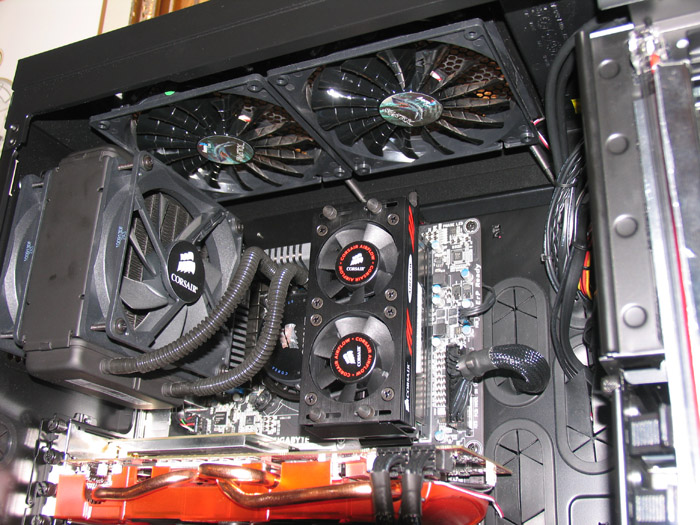Considering the components visible in this image, what could be the approximate total power consumption of the system when under full load, and which component is likely to be the largest consumer of power? Based on the visible components in the image, we can estimate the total power consumption of the system when under full load by summing up the power requirements of the CPU, GPU, RAM, motherboard, and cooling system. The high-end GPU visible, likely from a brand such as GIGABYTE, can often demand around 250 watts or more. A high-performance CPU usually requires between 95 to 140 watts. Meanwhile, RAM and the motherboard consume relatively minor amounts compared to the other components. The all-in-one (AIO) cooler introduced here would also draw power, though again less than the GPU and CPU. Given these typical power requirements, the GPU is likely the largest consumer of power, especially during graphically intensive operations. Altogether, depending on the specific models, you can anticipate the total power consumption under full load to reach between 400 to 600 watts or potentially higher. 